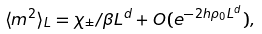Convert formula to latex. <formula><loc_0><loc_0><loc_500><loc_500>\langle m ^ { 2 } \rangle _ { L } = \chi _ { \pm } / \beta L ^ { d } + O ( e ^ { - 2 h \rho _ { 0 } L ^ { d } } ) ,</formula> 